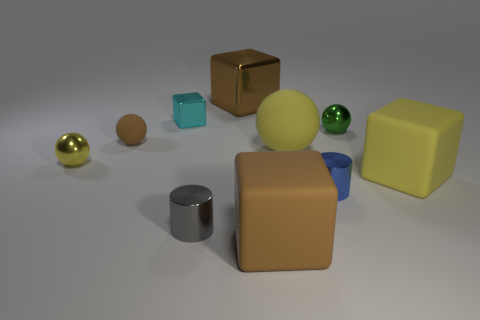There is a blue thing that is the same shape as the tiny gray shiny object; what is its material?
Offer a very short reply. Metal. There is a brown object that is in front of the yellow block; does it have the same shape as the large brown object that is behind the small blue metal cylinder?
Your answer should be compact. Yes. Are there any tiny yellow objects made of the same material as the tiny block?
Your response must be concise. Yes. The tiny shiny block has what color?
Provide a succinct answer. Cyan. What size is the shiny sphere that is on the right side of the yellow metal thing?
Offer a terse response. Small. How many shiny objects have the same color as the big matte sphere?
Make the answer very short. 1. Are there any matte spheres to the right of the metallic thing that is behind the small metal block?
Offer a very short reply. Yes. Does the big cube in front of the tiny gray thing have the same color as the large block that is behind the small yellow metallic ball?
Ensure brevity in your answer.  Yes. There is a metallic block that is the same size as the gray cylinder; what is its color?
Give a very brief answer. Cyan. Is the number of small rubber things left of the blue cylinder the same as the number of small cyan things on the right side of the big metal cube?
Ensure brevity in your answer.  No. 